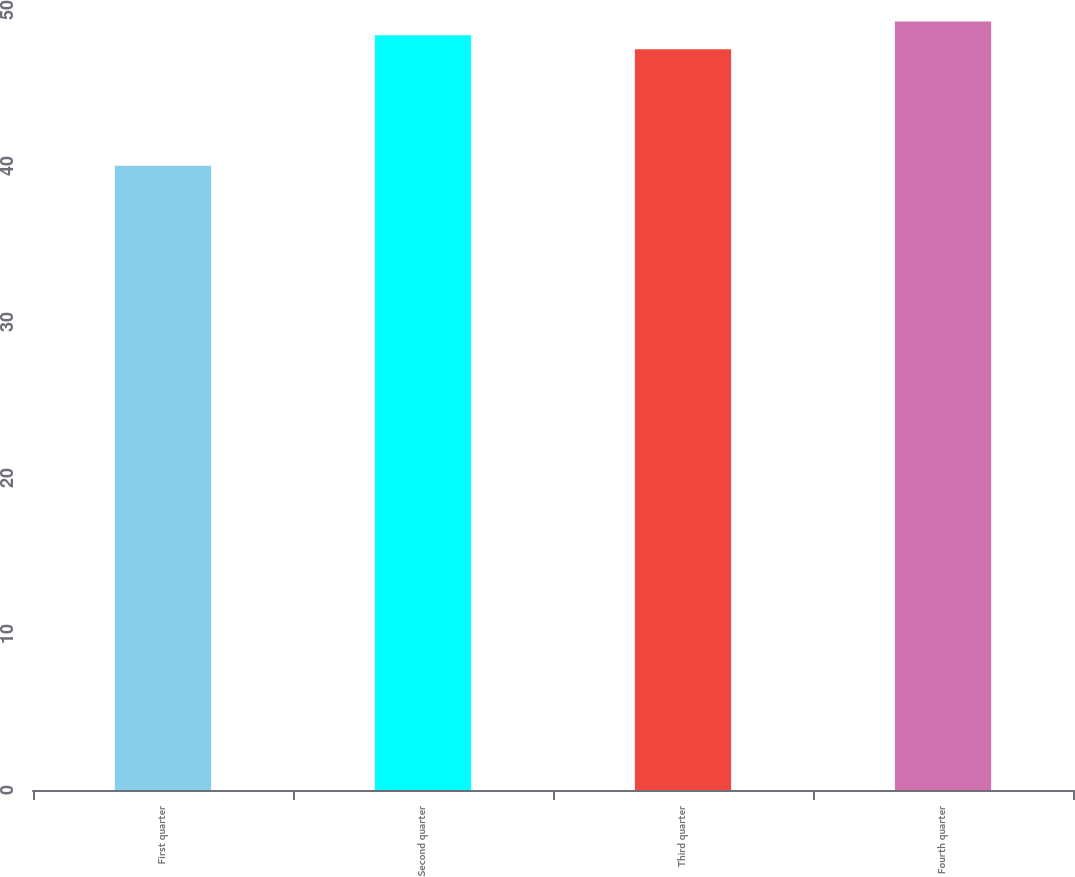<chart> <loc_0><loc_0><loc_500><loc_500><bar_chart><fcel>First quarter<fcel>Second quarter<fcel>Third quarter<fcel>Fourth quarter<nl><fcel>40.01<fcel>48.38<fcel>47.49<fcel>49.27<nl></chart> 